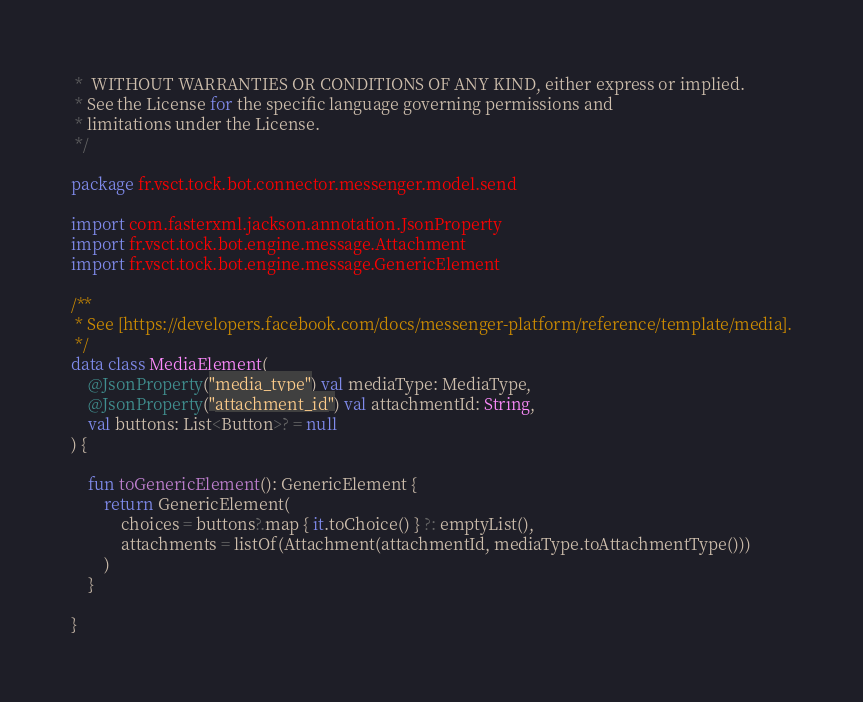Convert code to text. <code><loc_0><loc_0><loc_500><loc_500><_Kotlin_> *  WITHOUT WARRANTIES OR CONDITIONS OF ANY KIND, either express or implied.
 * See the License for the specific language governing permissions and
 * limitations under the License.
 */

package fr.vsct.tock.bot.connector.messenger.model.send

import com.fasterxml.jackson.annotation.JsonProperty
import fr.vsct.tock.bot.engine.message.Attachment
import fr.vsct.tock.bot.engine.message.GenericElement

/**
 * See [https://developers.facebook.com/docs/messenger-platform/reference/template/media].
 */
data class MediaElement(
    @JsonProperty("media_type") val mediaType: MediaType,
    @JsonProperty("attachment_id") val attachmentId: String,
    val buttons: List<Button>? = null
) {

    fun toGenericElement(): GenericElement {
        return GenericElement(
            choices = buttons?.map { it.toChoice() } ?: emptyList(),
            attachments = listOf(Attachment(attachmentId, mediaType.toAttachmentType()))
        )
    }

}</code> 